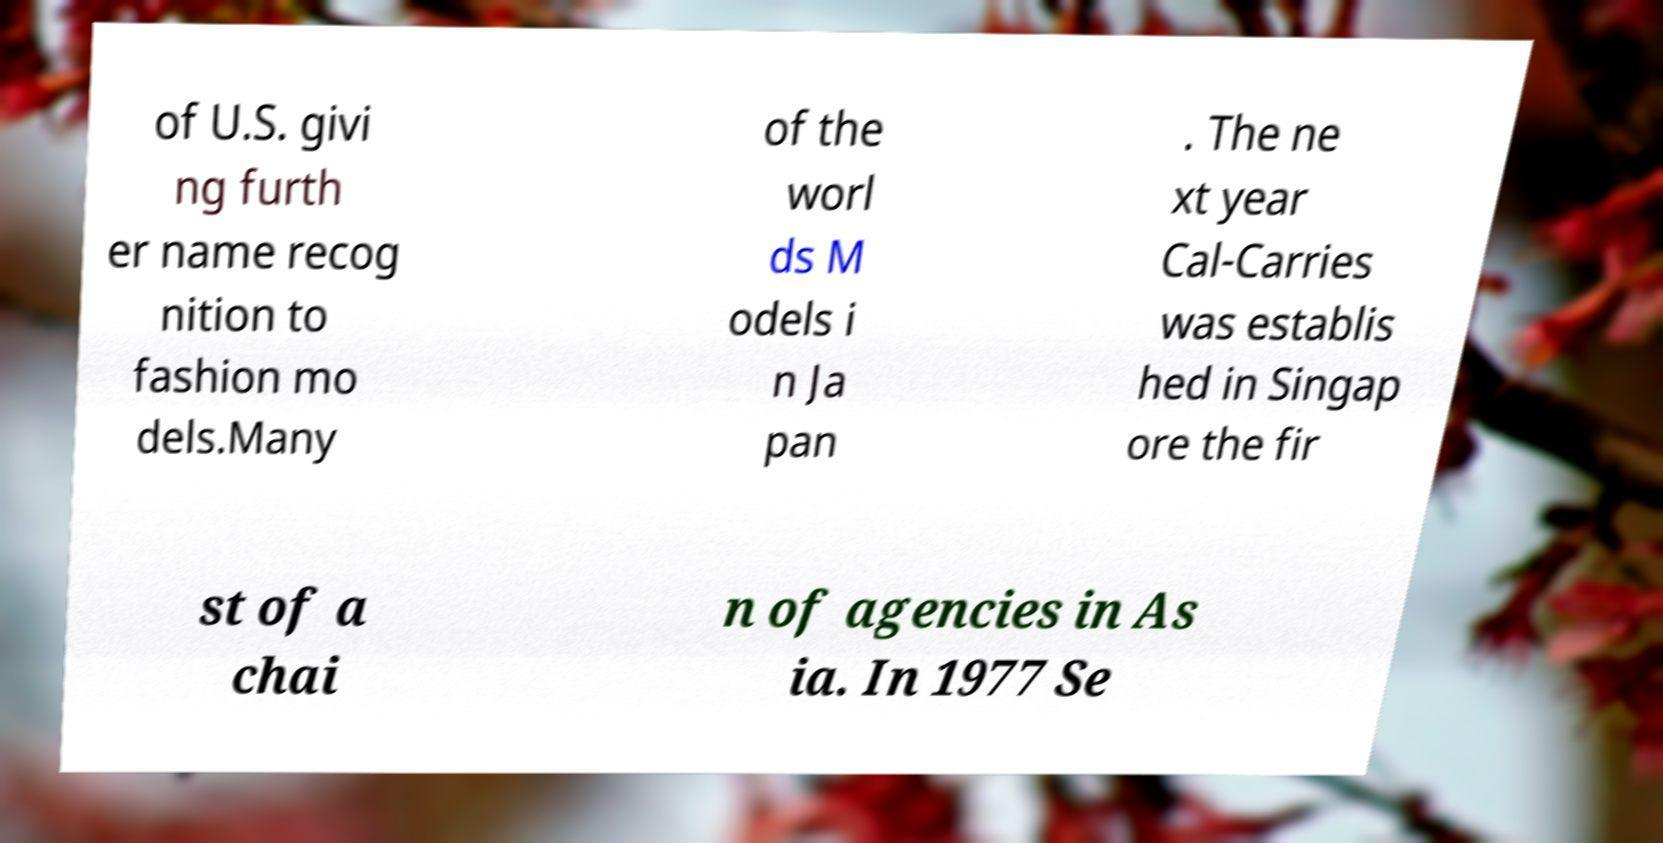Can you accurately transcribe the text from the provided image for me? of U.S. givi ng furth er name recog nition to fashion mo dels.Many of the worl ds M odels i n Ja pan . The ne xt year Cal-Carries was establis hed in Singap ore the fir st of a chai n of agencies in As ia. In 1977 Se 